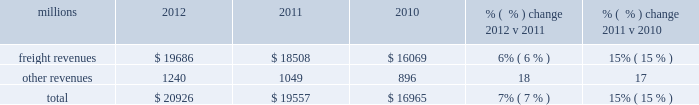F0b7 positive train control 2013 in response to a legislative mandate to implement ptc , we expect to spend approximately $ 450 million during 2013 on developing and deploying ptc .
We currently estimate that ptc , in accordance with implementing rules issued by the federal rail administration ( fra ) , will cost us approximately $ 2 billion by the end of the project .
This includes costs for installing the new system along our tracks , upgrading locomotives to work with the new system , and adding digital data communication equipment to integrate the components of the system .
F0b7 financial expectations 2013 we are cautious about the economic environment but if industrial production grows approximately 2% ( 2 % ) as projected , volume should exceed 2012 levels .
Even with no volume growth , we expect earnings to exceed 2012 earnings , generated by real core pricing gains , on-going network improvements and operational productivity initiatives .
We also expect that a new bonus depreciation program under federal tax laws will positively impact cash flows in 2013 .
Results of operations operating revenues millions 2012 2011 2010 % (  % ) change 2012 v 2011 % (  % ) change 2011 v 2010 .
We generate freight revenues by transporting freight or other materials from our six commodity groups .
Freight revenues vary with volume ( carloads ) and average revenue per car ( arc ) .
Changes in price , traffic mix and fuel surcharges drive arc .
We provide some of our customers with contractual incentives for meeting or exceeding specified cumulative volumes or shipping to and from specific locations , which we record as reductions to freight revenues based on the actual or projected future shipments .
We recognize freight revenues as shipments move from origin to destination .
We allocate freight revenues between reporting periods based on the relative transit time in each reporting period and recognize expenses as we incur them .
Other revenues include revenues earned by our subsidiaries , revenues from our commuter rail operations , and accessorial revenues , which we earn when customers retain equipment owned or controlled by us or when we perform additional services such as switching or storage .
We recognize other revenues as we perform services or meet contractual obligations .
Freight revenues from four of our six commodity groups increased during 2012 compared to 2011 .
Revenues from coal and agricultural products declined during the year .
Our franchise diversity allowed us to take advantage of growth from shale-related markets ( crude oil , frac sand and pipe ) and strong automotive manufacturing , which offset volume declines from coal and agricultural products .
Arc increased 7% ( 7 % ) , driven by core pricing gains and higher fuel cost recoveries .
Improved fuel recovery provisions and higher fuel prices , including the lag effect of our programs ( surcharges trail fluctuations in fuel price by approximately two months ) , combined to increase revenues from fuel surcharges .
Freight revenues for all six commodity groups increased during 2011 compared to 2010 , while volume increased in all commodity groups except intermodal .
Increased demand in many market sectors , with particularly strong growth in chemicals , industrial products , and automotive shipments for the year , generated the increases .
Arc increased 12% ( 12 % ) , driven by higher fuel cost recoveries and core pricing gains .
Fuel cost recoveries include fuel surcharge revenue and the impact of resetting the base fuel price for certain traffic .
Higher fuel prices , volume growth , and new fuel surcharge provisions in renegotiated contracts all combined to increase revenues from fuel surcharges .
Our fuel surcharge programs ( excluding index-based contract escalators that contain some provision for fuel ) generated freight revenues of $ 2.6 billion , $ 2.2 billion , and $ 1.2 billion in 2012 , 2011 , and 2010 , respectively .
Ongoing rising fuel prices and increased fuel surcharge coverage drove the increases .
Additionally , fuel surcharge revenue is not entirely comparable to prior periods as we continue to convert portions of our non-regulated traffic to mileage-based fuel surcharge programs. .
If 2012 total revenue increases at the same pace as arc in the chemicals , industrial products , and automotive businesses , what would 2013 revenue be in millions? 
Computations: (20926 + 12%)
Answer: 20926.12. 